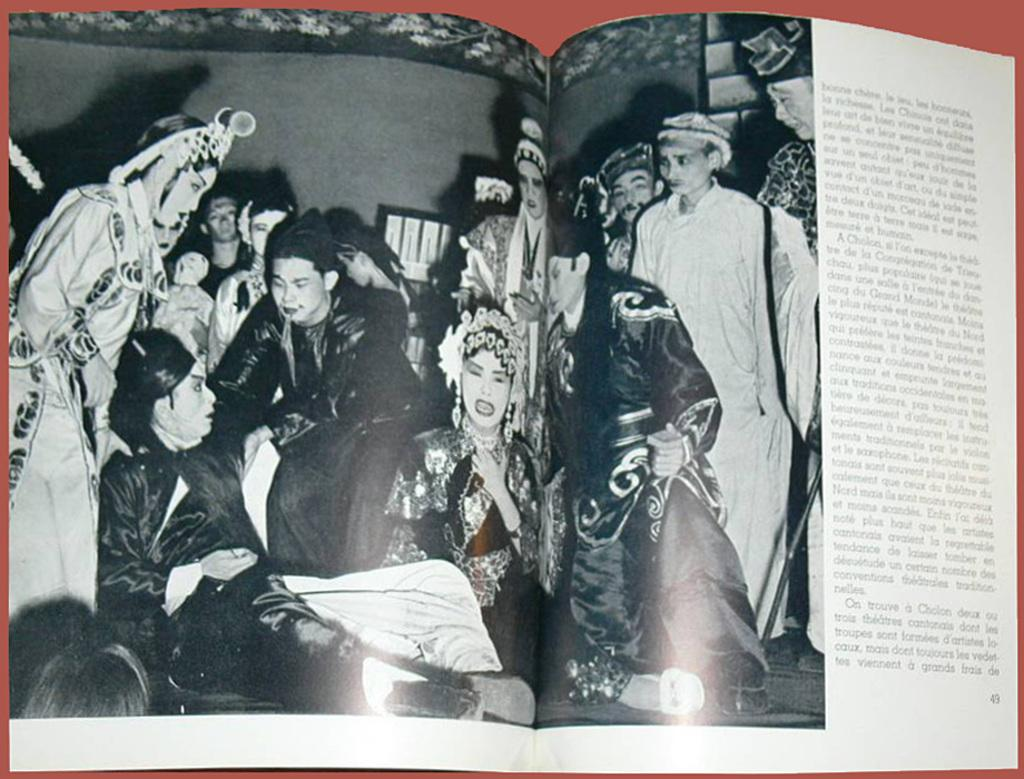What object can be seen in the image? There is a book in the image. Where is the book located? The book is placed on a table. What type of advice is the book giving in the image? The image does not show the book giving any advice, as it is a static object. 